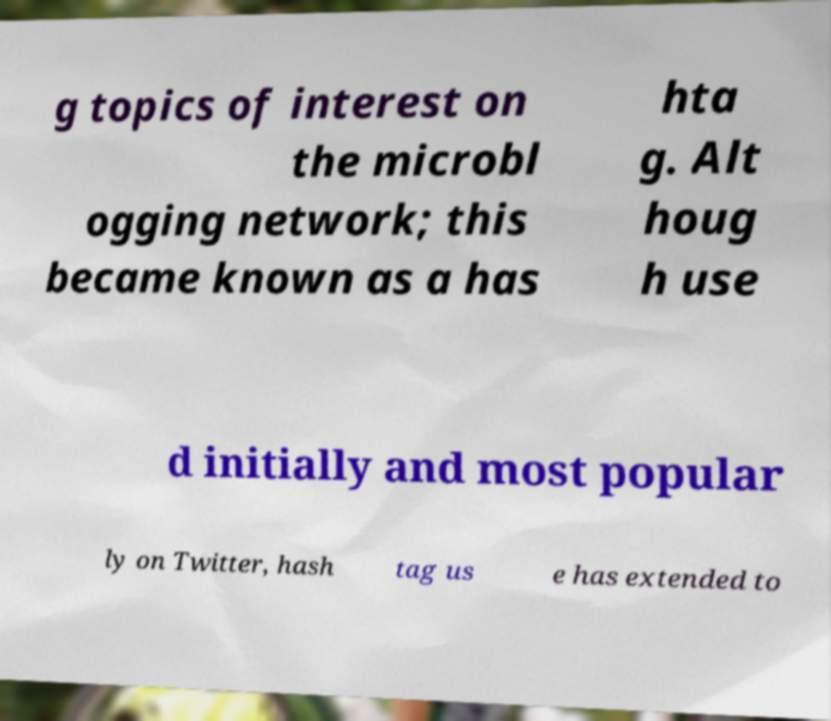What messages or text are displayed in this image? I need them in a readable, typed format. g topics of interest on the microbl ogging network; this became known as a has hta g. Alt houg h use d initially and most popular ly on Twitter, hash tag us e has extended to 